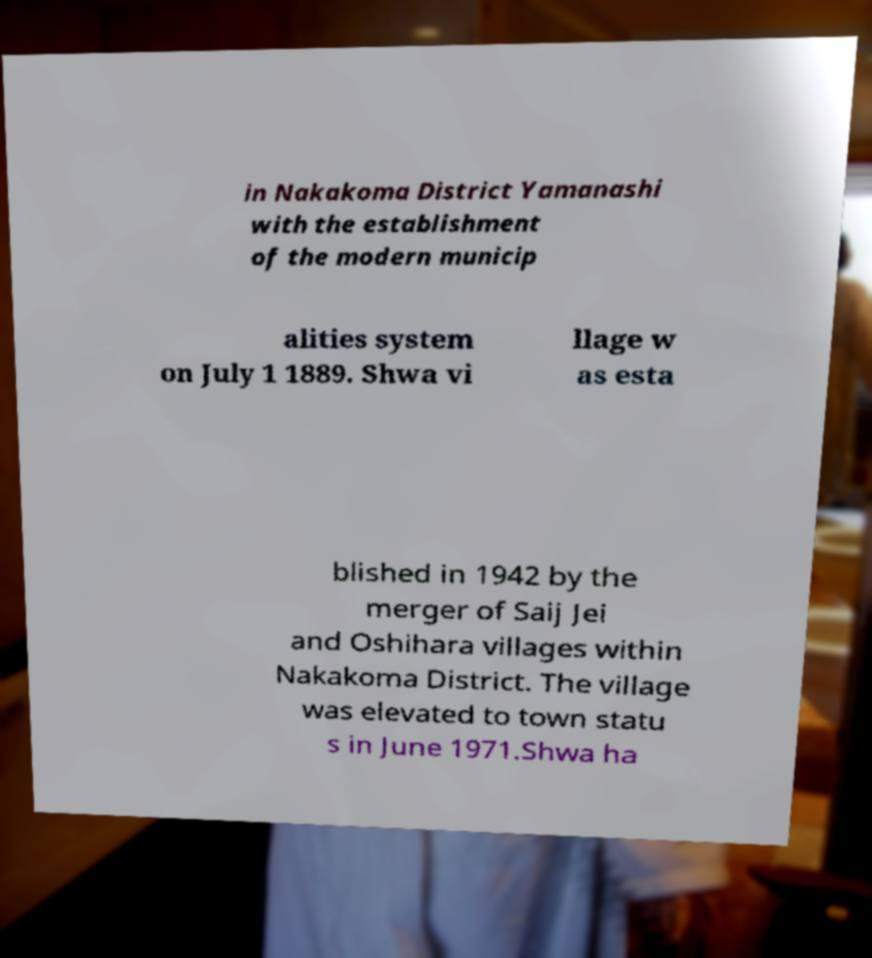Can you accurately transcribe the text from the provided image for me? in Nakakoma District Yamanashi with the establishment of the modern municip alities system on July 1 1889. Shwa vi llage w as esta blished in 1942 by the merger of Saij Jei and Oshihara villages within Nakakoma District. The village was elevated to town statu s in June 1971.Shwa ha 